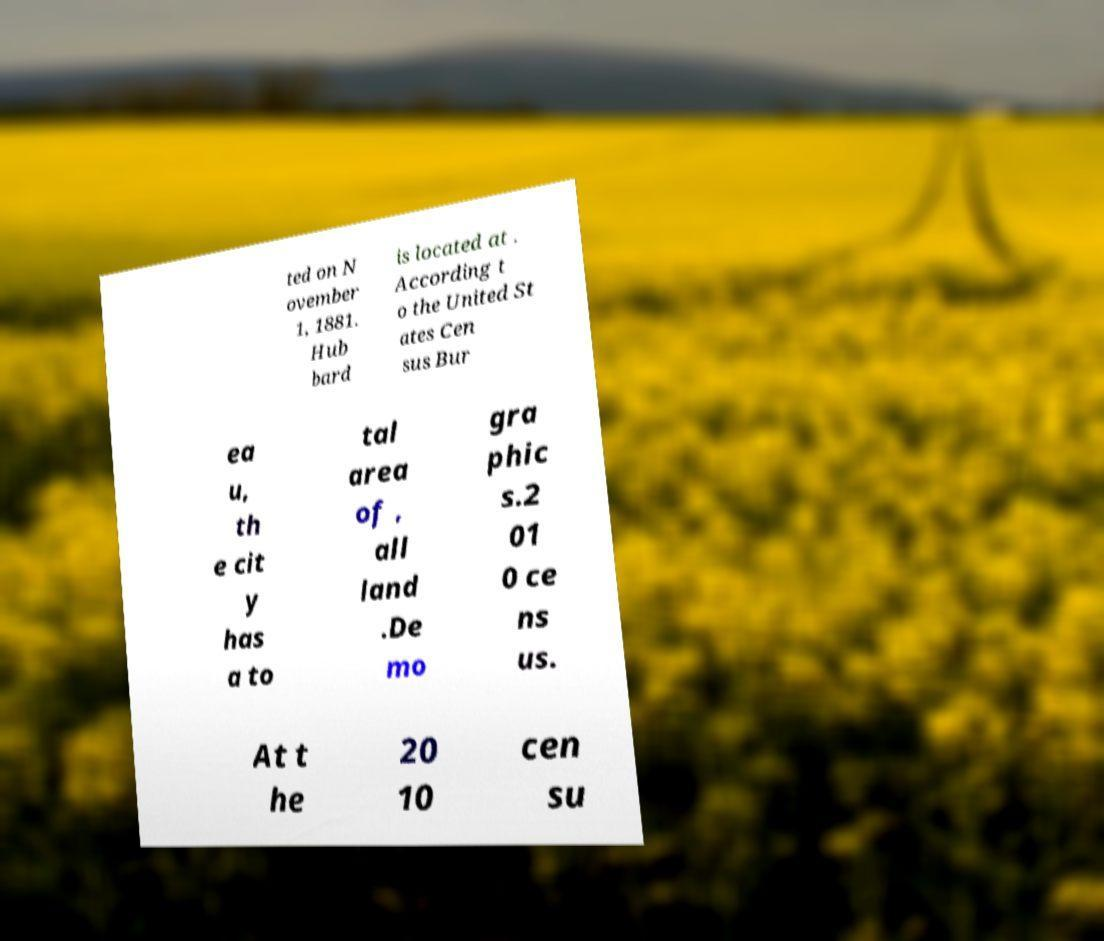What messages or text are displayed in this image? I need them in a readable, typed format. ted on N ovember 1, 1881. Hub bard is located at . According t o the United St ates Cen sus Bur ea u, th e cit y has a to tal area of , all land .De mo gra phic s.2 01 0 ce ns us. At t he 20 10 cen su 